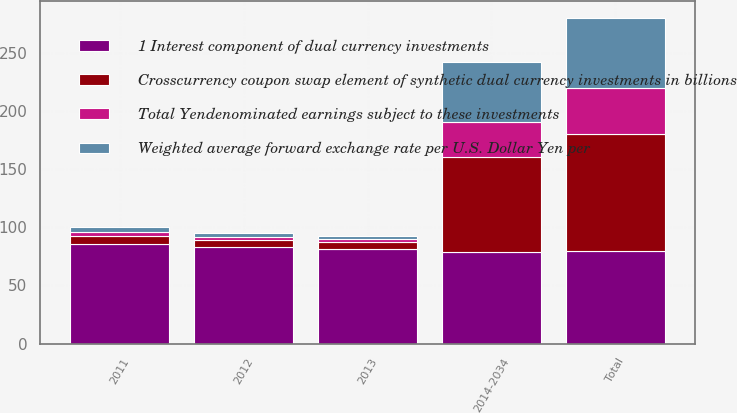Convert chart. <chart><loc_0><loc_0><loc_500><loc_500><stacked_bar_chart><ecel><fcel>2011<fcel>2012<fcel>2013<fcel>2014-2034<fcel>Total<nl><fcel>Total Yendenominated earnings subject to these investments<fcel>3.4<fcel>3.1<fcel>2.9<fcel>30.4<fcel>39.8<nl><fcel>Weighted average forward exchange rate per U.S. Dollar Yen per<fcel>3.9<fcel>2.9<fcel>2.5<fcel>51.1<fcel>60.4<nl><fcel>Crosscurrency coupon swap element of synthetic dual currency investments in billions<fcel>7.3<fcel>6<fcel>5.4<fcel>81.5<fcel>100.2<nl><fcel>1 Interest component of dual currency investments<fcel>85.3<fcel>83<fcel>81.6<fcel>79.2<fcel>80<nl></chart> 